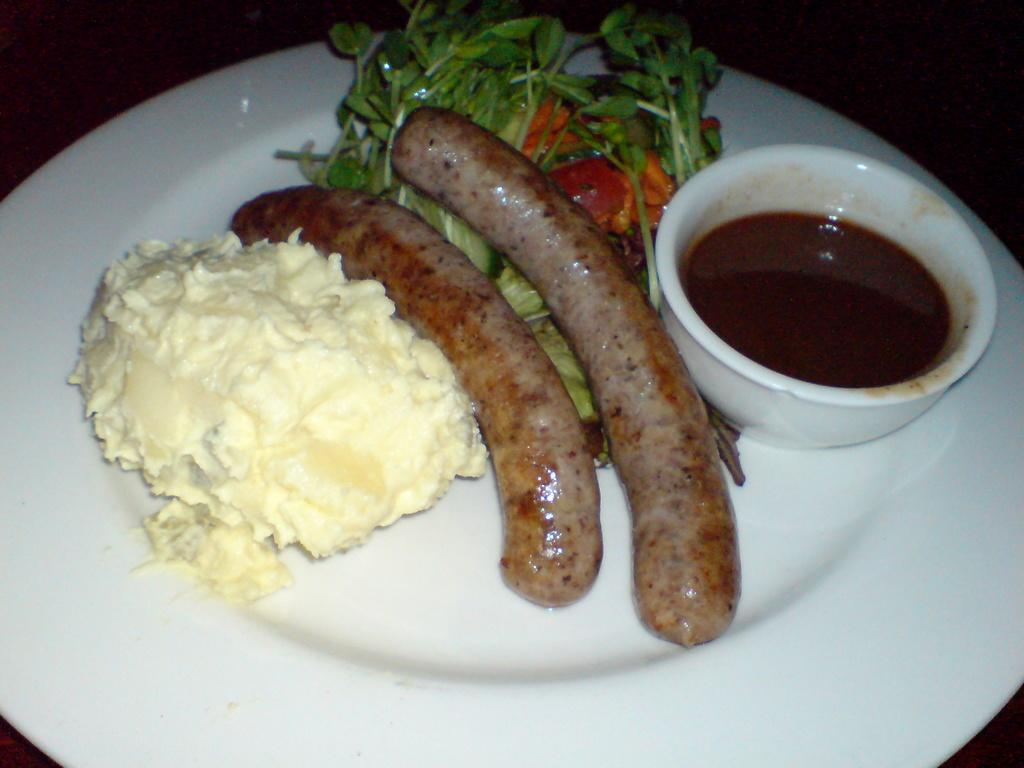What type of food is on the plate in the image? There is food in a plate in the image, but the specific type of food is not mentioned. What is in the bowl in the image? There is soup in a bowl in the image. What type of ring is visible on the moon in the image? There is no mention of a ring or the moon in the image; it only features food on a plate and soup in a bowl. 